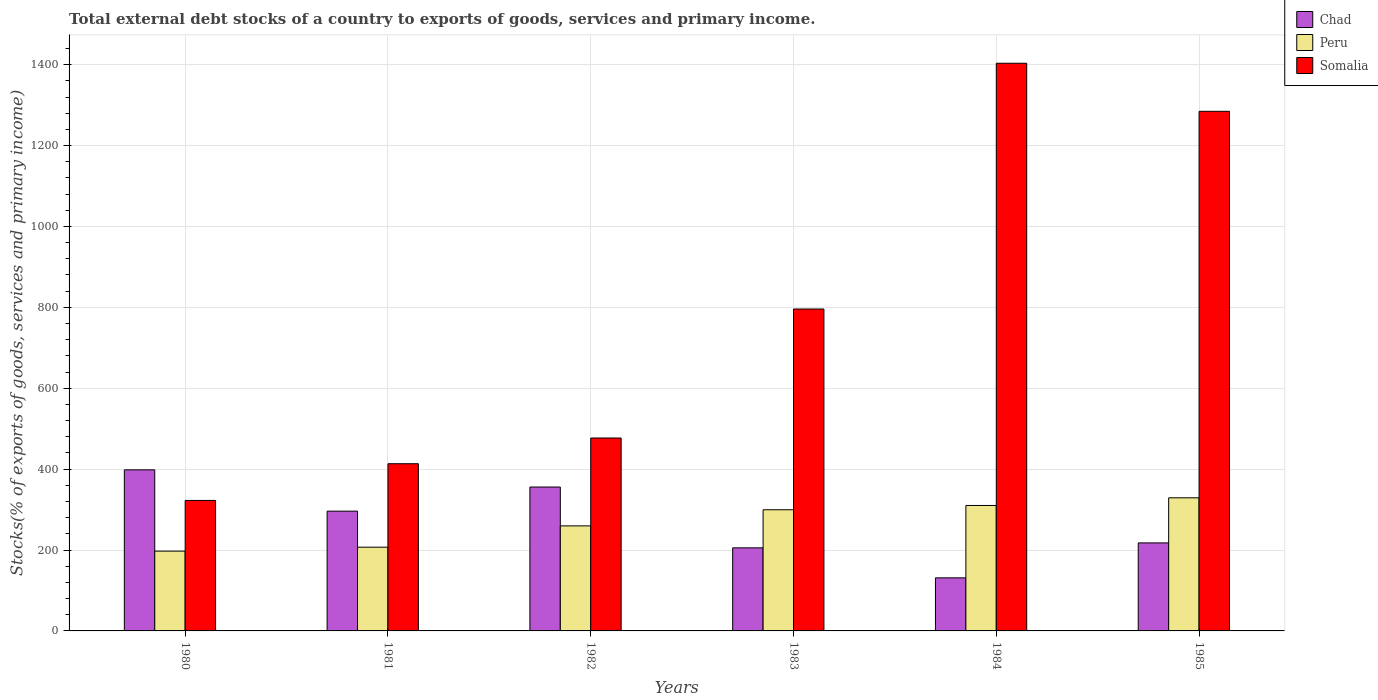How many groups of bars are there?
Give a very brief answer. 6. Are the number of bars per tick equal to the number of legend labels?
Offer a very short reply. Yes. Are the number of bars on each tick of the X-axis equal?
Offer a very short reply. Yes. What is the label of the 1st group of bars from the left?
Offer a terse response. 1980. In how many cases, is the number of bars for a given year not equal to the number of legend labels?
Provide a succinct answer. 0. What is the total debt stocks in Chad in 1981?
Offer a very short reply. 296.1. Across all years, what is the maximum total debt stocks in Peru?
Make the answer very short. 329.13. Across all years, what is the minimum total debt stocks in Chad?
Keep it short and to the point. 131.2. In which year was the total debt stocks in Peru minimum?
Your answer should be compact. 1980. What is the total total debt stocks in Peru in the graph?
Your answer should be compact. 1602.91. What is the difference between the total debt stocks in Somalia in 1982 and that in 1985?
Provide a short and direct response. -807.72. What is the difference between the total debt stocks in Peru in 1982 and the total debt stocks in Chad in 1983?
Offer a terse response. 54.3. What is the average total debt stocks in Chad per year?
Keep it short and to the point. 267.39. In the year 1980, what is the difference between the total debt stocks in Chad and total debt stocks in Somalia?
Provide a succinct answer. 75.62. What is the ratio of the total debt stocks in Chad in 1980 to that in 1983?
Provide a succinct answer. 1.94. Is the total debt stocks in Somalia in 1984 less than that in 1985?
Your answer should be very brief. No. Is the difference between the total debt stocks in Chad in 1980 and 1983 greater than the difference between the total debt stocks in Somalia in 1980 and 1983?
Your answer should be very brief. Yes. What is the difference between the highest and the second highest total debt stocks in Chad?
Provide a short and direct response. 42.5. What is the difference between the highest and the lowest total debt stocks in Somalia?
Offer a very short reply. 1080.82. In how many years, is the total debt stocks in Somalia greater than the average total debt stocks in Somalia taken over all years?
Ensure brevity in your answer.  3. What does the 1st bar from the left in 1983 represents?
Keep it short and to the point. Chad. What does the 3rd bar from the right in 1983 represents?
Give a very brief answer. Chad. How many bars are there?
Offer a very short reply. 18. Are all the bars in the graph horizontal?
Keep it short and to the point. No. How many years are there in the graph?
Your response must be concise. 6. How many legend labels are there?
Keep it short and to the point. 3. How are the legend labels stacked?
Offer a terse response. Vertical. What is the title of the graph?
Your answer should be very brief. Total external debt stocks of a country to exports of goods, services and primary income. What is the label or title of the X-axis?
Keep it short and to the point. Years. What is the label or title of the Y-axis?
Give a very brief answer. Stocks(% of exports of goods, services and primary income). What is the Stocks(% of exports of goods, services and primary income) of Chad in 1980?
Your answer should be very brief. 398.26. What is the Stocks(% of exports of goods, services and primary income) of Peru in 1980?
Provide a succinct answer. 197.3. What is the Stocks(% of exports of goods, services and primary income) in Somalia in 1980?
Your response must be concise. 322.64. What is the Stocks(% of exports of goods, services and primary income) in Chad in 1981?
Offer a very short reply. 296.1. What is the Stocks(% of exports of goods, services and primary income) of Peru in 1981?
Your response must be concise. 207.03. What is the Stocks(% of exports of goods, services and primary income) in Somalia in 1981?
Provide a succinct answer. 413.36. What is the Stocks(% of exports of goods, services and primary income) in Chad in 1982?
Your response must be concise. 355.75. What is the Stocks(% of exports of goods, services and primary income) in Peru in 1982?
Ensure brevity in your answer.  259.7. What is the Stocks(% of exports of goods, services and primary income) in Somalia in 1982?
Provide a succinct answer. 476.97. What is the Stocks(% of exports of goods, services and primary income) in Chad in 1983?
Offer a terse response. 205.4. What is the Stocks(% of exports of goods, services and primary income) of Peru in 1983?
Give a very brief answer. 299.59. What is the Stocks(% of exports of goods, services and primary income) in Somalia in 1983?
Your answer should be very brief. 795.87. What is the Stocks(% of exports of goods, services and primary income) in Chad in 1984?
Your answer should be very brief. 131.2. What is the Stocks(% of exports of goods, services and primary income) of Peru in 1984?
Your response must be concise. 310.16. What is the Stocks(% of exports of goods, services and primary income) of Somalia in 1984?
Your response must be concise. 1403.46. What is the Stocks(% of exports of goods, services and primary income) in Chad in 1985?
Your response must be concise. 217.61. What is the Stocks(% of exports of goods, services and primary income) of Peru in 1985?
Your answer should be compact. 329.13. What is the Stocks(% of exports of goods, services and primary income) in Somalia in 1985?
Offer a very short reply. 1284.68. Across all years, what is the maximum Stocks(% of exports of goods, services and primary income) in Chad?
Ensure brevity in your answer.  398.26. Across all years, what is the maximum Stocks(% of exports of goods, services and primary income) of Peru?
Provide a short and direct response. 329.13. Across all years, what is the maximum Stocks(% of exports of goods, services and primary income) of Somalia?
Give a very brief answer. 1403.46. Across all years, what is the minimum Stocks(% of exports of goods, services and primary income) in Chad?
Your answer should be compact. 131.2. Across all years, what is the minimum Stocks(% of exports of goods, services and primary income) of Peru?
Offer a very short reply. 197.3. Across all years, what is the minimum Stocks(% of exports of goods, services and primary income) of Somalia?
Give a very brief answer. 322.64. What is the total Stocks(% of exports of goods, services and primary income) of Chad in the graph?
Provide a short and direct response. 1604.32. What is the total Stocks(% of exports of goods, services and primary income) of Peru in the graph?
Provide a succinct answer. 1602.91. What is the total Stocks(% of exports of goods, services and primary income) of Somalia in the graph?
Ensure brevity in your answer.  4696.98. What is the difference between the Stocks(% of exports of goods, services and primary income) in Chad in 1980 and that in 1981?
Provide a succinct answer. 102.15. What is the difference between the Stocks(% of exports of goods, services and primary income) of Peru in 1980 and that in 1981?
Your response must be concise. -9.73. What is the difference between the Stocks(% of exports of goods, services and primary income) in Somalia in 1980 and that in 1981?
Provide a short and direct response. -90.72. What is the difference between the Stocks(% of exports of goods, services and primary income) in Chad in 1980 and that in 1982?
Your answer should be compact. 42.5. What is the difference between the Stocks(% of exports of goods, services and primary income) of Peru in 1980 and that in 1982?
Your response must be concise. -62.4. What is the difference between the Stocks(% of exports of goods, services and primary income) in Somalia in 1980 and that in 1982?
Offer a terse response. -154.33. What is the difference between the Stocks(% of exports of goods, services and primary income) of Chad in 1980 and that in 1983?
Offer a terse response. 192.85. What is the difference between the Stocks(% of exports of goods, services and primary income) of Peru in 1980 and that in 1983?
Ensure brevity in your answer.  -102.29. What is the difference between the Stocks(% of exports of goods, services and primary income) of Somalia in 1980 and that in 1983?
Your answer should be very brief. -473.23. What is the difference between the Stocks(% of exports of goods, services and primary income) in Chad in 1980 and that in 1984?
Your response must be concise. 267.06. What is the difference between the Stocks(% of exports of goods, services and primary income) of Peru in 1980 and that in 1984?
Your response must be concise. -112.86. What is the difference between the Stocks(% of exports of goods, services and primary income) in Somalia in 1980 and that in 1984?
Your answer should be compact. -1080.82. What is the difference between the Stocks(% of exports of goods, services and primary income) in Chad in 1980 and that in 1985?
Your answer should be very brief. 180.65. What is the difference between the Stocks(% of exports of goods, services and primary income) of Peru in 1980 and that in 1985?
Give a very brief answer. -131.83. What is the difference between the Stocks(% of exports of goods, services and primary income) of Somalia in 1980 and that in 1985?
Ensure brevity in your answer.  -962.05. What is the difference between the Stocks(% of exports of goods, services and primary income) of Chad in 1981 and that in 1982?
Give a very brief answer. -59.65. What is the difference between the Stocks(% of exports of goods, services and primary income) of Peru in 1981 and that in 1982?
Provide a succinct answer. -52.67. What is the difference between the Stocks(% of exports of goods, services and primary income) of Somalia in 1981 and that in 1982?
Ensure brevity in your answer.  -63.61. What is the difference between the Stocks(% of exports of goods, services and primary income) in Chad in 1981 and that in 1983?
Keep it short and to the point. 90.7. What is the difference between the Stocks(% of exports of goods, services and primary income) in Peru in 1981 and that in 1983?
Your answer should be very brief. -92.56. What is the difference between the Stocks(% of exports of goods, services and primary income) of Somalia in 1981 and that in 1983?
Make the answer very short. -382.51. What is the difference between the Stocks(% of exports of goods, services and primary income) of Chad in 1981 and that in 1984?
Offer a very short reply. 164.91. What is the difference between the Stocks(% of exports of goods, services and primary income) in Peru in 1981 and that in 1984?
Provide a short and direct response. -103.13. What is the difference between the Stocks(% of exports of goods, services and primary income) of Somalia in 1981 and that in 1984?
Your answer should be compact. -990.1. What is the difference between the Stocks(% of exports of goods, services and primary income) in Chad in 1981 and that in 1985?
Offer a terse response. 78.49. What is the difference between the Stocks(% of exports of goods, services and primary income) in Peru in 1981 and that in 1985?
Provide a succinct answer. -122.1. What is the difference between the Stocks(% of exports of goods, services and primary income) in Somalia in 1981 and that in 1985?
Your answer should be compact. -871.33. What is the difference between the Stocks(% of exports of goods, services and primary income) of Chad in 1982 and that in 1983?
Your answer should be compact. 150.35. What is the difference between the Stocks(% of exports of goods, services and primary income) in Peru in 1982 and that in 1983?
Give a very brief answer. -39.89. What is the difference between the Stocks(% of exports of goods, services and primary income) in Somalia in 1982 and that in 1983?
Keep it short and to the point. -318.9. What is the difference between the Stocks(% of exports of goods, services and primary income) of Chad in 1982 and that in 1984?
Make the answer very short. 224.56. What is the difference between the Stocks(% of exports of goods, services and primary income) in Peru in 1982 and that in 1984?
Keep it short and to the point. -50.45. What is the difference between the Stocks(% of exports of goods, services and primary income) in Somalia in 1982 and that in 1984?
Your answer should be compact. -926.49. What is the difference between the Stocks(% of exports of goods, services and primary income) in Chad in 1982 and that in 1985?
Offer a very short reply. 138.14. What is the difference between the Stocks(% of exports of goods, services and primary income) of Peru in 1982 and that in 1985?
Your response must be concise. -69.43. What is the difference between the Stocks(% of exports of goods, services and primary income) of Somalia in 1982 and that in 1985?
Make the answer very short. -807.72. What is the difference between the Stocks(% of exports of goods, services and primary income) of Chad in 1983 and that in 1984?
Give a very brief answer. 74.21. What is the difference between the Stocks(% of exports of goods, services and primary income) in Peru in 1983 and that in 1984?
Offer a very short reply. -10.57. What is the difference between the Stocks(% of exports of goods, services and primary income) of Somalia in 1983 and that in 1984?
Give a very brief answer. -607.59. What is the difference between the Stocks(% of exports of goods, services and primary income) of Chad in 1983 and that in 1985?
Give a very brief answer. -12.2. What is the difference between the Stocks(% of exports of goods, services and primary income) in Peru in 1983 and that in 1985?
Your response must be concise. -29.54. What is the difference between the Stocks(% of exports of goods, services and primary income) of Somalia in 1983 and that in 1985?
Keep it short and to the point. -488.81. What is the difference between the Stocks(% of exports of goods, services and primary income) in Chad in 1984 and that in 1985?
Your answer should be compact. -86.41. What is the difference between the Stocks(% of exports of goods, services and primary income) of Peru in 1984 and that in 1985?
Offer a terse response. -18.97. What is the difference between the Stocks(% of exports of goods, services and primary income) of Somalia in 1984 and that in 1985?
Your answer should be very brief. 118.78. What is the difference between the Stocks(% of exports of goods, services and primary income) of Chad in 1980 and the Stocks(% of exports of goods, services and primary income) of Peru in 1981?
Keep it short and to the point. 191.23. What is the difference between the Stocks(% of exports of goods, services and primary income) of Chad in 1980 and the Stocks(% of exports of goods, services and primary income) of Somalia in 1981?
Offer a very short reply. -15.1. What is the difference between the Stocks(% of exports of goods, services and primary income) in Peru in 1980 and the Stocks(% of exports of goods, services and primary income) in Somalia in 1981?
Give a very brief answer. -216.06. What is the difference between the Stocks(% of exports of goods, services and primary income) of Chad in 1980 and the Stocks(% of exports of goods, services and primary income) of Peru in 1982?
Offer a terse response. 138.55. What is the difference between the Stocks(% of exports of goods, services and primary income) in Chad in 1980 and the Stocks(% of exports of goods, services and primary income) in Somalia in 1982?
Your answer should be very brief. -78.71. What is the difference between the Stocks(% of exports of goods, services and primary income) of Peru in 1980 and the Stocks(% of exports of goods, services and primary income) of Somalia in 1982?
Your answer should be very brief. -279.67. What is the difference between the Stocks(% of exports of goods, services and primary income) in Chad in 1980 and the Stocks(% of exports of goods, services and primary income) in Peru in 1983?
Offer a very short reply. 98.67. What is the difference between the Stocks(% of exports of goods, services and primary income) of Chad in 1980 and the Stocks(% of exports of goods, services and primary income) of Somalia in 1983?
Provide a short and direct response. -397.61. What is the difference between the Stocks(% of exports of goods, services and primary income) of Peru in 1980 and the Stocks(% of exports of goods, services and primary income) of Somalia in 1983?
Offer a terse response. -598.57. What is the difference between the Stocks(% of exports of goods, services and primary income) in Chad in 1980 and the Stocks(% of exports of goods, services and primary income) in Peru in 1984?
Provide a short and direct response. 88.1. What is the difference between the Stocks(% of exports of goods, services and primary income) of Chad in 1980 and the Stocks(% of exports of goods, services and primary income) of Somalia in 1984?
Your answer should be very brief. -1005.2. What is the difference between the Stocks(% of exports of goods, services and primary income) of Peru in 1980 and the Stocks(% of exports of goods, services and primary income) of Somalia in 1984?
Your answer should be compact. -1206.16. What is the difference between the Stocks(% of exports of goods, services and primary income) in Chad in 1980 and the Stocks(% of exports of goods, services and primary income) in Peru in 1985?
Your answer should be very brief. 69.13. What is the difference between the Stocks(% of exports of goods, services and primary income) in Chad in 1980 and the Stocks(% of exports of goods, services and primary income) in Somalia in 1985?
Offer a terse response. -886.43. What is the difference between the Stocks(% of exports of goods, services and primary income) in Peru in 1980 and the Stocks(% of exports of goods, services and primary income) in Somalia in 1985?
Offer a terse response. -1087.38. What is the difference between the Stocks(% of exports of goods, services and primary income) of Chad in 1981 and the Stocks(% of exports of goods, services and primary income) of Peru in 1982?
Provide a succinct answer. 36.4. What is the difference between the Stocks(% of exports of goods, services and primary income) of Chad in 1981 and the Stocks(% of exports of goods, services and primary income) of Somalia in 1982?
Your response must be concise. -180.86. What is the difference between the Stocks(% of exports of goods, services and primary income) of Peru in 1981 and the Stocks(% of exports of goods, services and primary income) of Somalia in 1982?
Your answer should be very brief. -269.94. What is the difference between the Stocks(% of exports of goods, services and primary income) in Chad in 1981 and the Stocks(% of exports of goods, services and primary income) in Peru in 1983?
Keep it short and to the point. -3.49. What is the difference between the Stocks(% of exports of goods, services and primary income) of Chad in 1981 and the Stocks(% of exports of goods, services and primary income) of Somalia in 1983?
Your answer should be very brief. -499.77. What is the difference between the Stocks(% of exports of goods, services and primary income) of Peru in 1981 and the Stocks(% of exports of goods, services and primary income) of Somalia in 1983?
Keep it short and to the point. -588.84. What is the difference between the Stocks(% of exports of goods, services and primary income) in Chad in 1981 and the Stocks(% of exports of goods, services and primary income) in Peru in 1984?
Keep it short and to the point. -14.06. What is the difference between the Stocks(% of exports of goods, services and primary income) of Chad in 1981 and the Stocks(% of exports of goods, services and primary income) of Somalia in 1984?
Your answer should be very brief. -1107.36. What is the difference between the Stocks(% of exports of goods, services and primary income) of Peru in 1981 and the Stocks(% of exports of goods, services and primary income) of Somalia in 1984?
Ensure brevity in your answer.  -1196.43. What is the difference between the Stocks(% of exports of goods, services and primary income) of Chad in 1981 and the Stocks(% of exports of goods, services and primary income) of Peru in 1985?
Give a very brief answer. -33.03. What is the difference between the Stocks(% of exports of goods, services and primary income) in Chad in 1981 and the Stocks(% of exports of goods, services and primary income) in Somalia in 1985?
Provide a succinct answer. -988.58. What is the difference between the Stocks(% of exports of goods, services and primary income) in Peru in 1981 and the Stocks(% of exports of goods, services and primary income) in Somalia in 1985?
Provide a succinct answer. -1077.66. What is the difference between the Stocks(% of exports of goods, services and primary income) in Chad in 1982 and the Stocks(% of exports of goods, services and primary income) in Peru in 1983?
Keep it short and to the point. 56.16. What is the difference between the Stocks(% of exports of goods, services and primary income) in Chad in 1982 and the Stocks(% of exports of goods, services and primary income) in Somalia in 1983?
Your answer should be compact. -440.12. What is the difference between the Stocks(% of exports of goods, services and primary income) in Peru in 1982 and the Stocks(% of exports of goods, services and primary income) in Somalia in 1983?
Your response must be concise. -536.17. What is the difference between the Stocks(% of exports of goods, services and primary income) in Chad in 1982 and the Stocks(% of exports of goods, services and primary income) in Peru in 1984?
Ensure brevity in your answer.  45.59. What is the difference between the Stocks(% of exports of goods, services and primary income) in Chad in 1982 and the Stocks(% of exports of goods, services and primary income) in Somalia in 1984?
Provide a succinct answer. -1047.71. What is the difference between the Stocks(% of exports of goods, services and primary income) in Peru in 1982 and the Stocks(% of exports of goods, services and primary income) in Somalia in 1984?
Provide a succinct answer. -1143.76. What is the difference between the Stocks(% of exports of goods, services and primary income) of Chad in 1982 and the Stocks(% of exports of goods, services and primary income) of Peru in 1985?
Your answer should be very brief. 26.62. What is the difference between the Stocks(% of exports of goods, services and primary income) of Chad in 1982 and the Stocks(% of exports of goods, services and primary income) of Somalia in 1985?
Your response must be concise. -928.93. What is the difference between the Stocks(% of exports of goods, services and primary income) of Peru in 1982 and the Stocks(% of exports of goods, services and primary income) of Somalia in 1985?
Your answer should be compact. -1024.98. What is the difference between the Stocks(% of exports of goods, services and primary income) in Chad in 1983 and the Stocks(% of exports of goods, services and primary income) in Peru in 1984?
Ensure brevity in your answer.  -104.75. What is the difference between the Stocks(% of exports of goods, services and primary income) of Chad in 1983 and the Stocks(% of exports of goods, services and primary income) of Somalia in 1984?
Give a very brief answer. -1198.06. What is the difference between the Stocks(% of exports of goods, services and primary income) of Peru in 1983 and the Stocks(% of exports of goods, services and primary income) of Somalia in 1984?
Make the answer very short. -1103.87. What is the difference between the Stocks(% of exports of goods, services and primary income) in Chad in 1983 and the Stocks(% of exports of goods, services and primary income) in Peru in 1985?
Your answer should be compact. -123.73. What is the difference between the Stocks(% of exports of goods, services and primary income) in Chad in 1983 and the Stocks(% of exports of goods, services and primary income) in Somalia in 1985?
Offer a terse response. -1079.28. What is the difference between the Stocks(% of exports of goods, services and primary income) in Peru in 1983 and the Stocks(% of exports of goods, services and primary income) in Somalia in 1985?
Your answer should be compact. -985.09. What is the difference between the Stocks(% of exports of goods, services and primary income) of Chad in 1984 and the Stocks(% of exports of goods, services and primary income) of Peru in 1985?
Ensure brevity in your answer.  -197.93. What is the difference between the Stocks(% of exports of goods, services and primary income) in Chad in 1984 and the Stocks(% of exports of goods, services and primary income) in Somalia in 1985?
Your response must be concise. -1153.49. What is the difference between the Stocks(% of exports of goods, services and primary income) in Peru in 1984 and the Stocks(% of exports of goods, services and primary income) in Somalia in 1985?
Offer a terse response. -974.53. What is the average Stocks(% of exports of goods, services and primary income) of Chad per year?
Your answer should be very brief. 267.39. What is the average Stocks(% of exports of goods, services and primary income) in Peru per year?
Ensure brevity in your answer.  267.15. What is the average Stocks(% of exports of goods, services and primary income) in Somalia per year?
Offer a terse response. 782.83. In the year 1980, what is the difference between the Stocks(% of exports of goods, services and primary income) of Chad and Stocks(% of exports of goods, services and primary income) of Peru?
Make the answer very short. 200.96. In the year 1980, what is the difference between the Stocks(% of exports of goods, services and primary income) of Chad and Stocks(% of exports of goods, services and primary income) of Somalia?
Make the answer very short. 75.62. In the year 1980, what is the difference between the Stocks(% of exports of goods, services and primary income) in Peru and Stocks(% of exports of goods, services and primary income) in Somalia?
Offer a terse response. -125.34. In the year 1981, what is the difference between the Stocks(% of exports of goods, services and primary income) of Chad and Stocks(% of exports of goods, services and primary income) of Peru?
Keep it short and to the point. 89.07. In the year 1981, what is the difference between the Stocks(% of exports of goods, services and primary income) in Chad and Stocks(% of exports of goods, services and primary income) in Somalia?
Your response must be concise. -117.26. In the year 1981, what is the difference between the Stocks(% of exports of goods, services and primary income) of Peru and Stocks(% of exports of goods, services and primary income) of Somalia?
Ensure brevity in your answer.  -206.33. In the year 1982, what is the difference between the Stocks(% of exports of goods, services and primary income) of Chad and Stocks(% of exports of goods, services and primary income) of Peru?
Keep it short and to the point. 96.05. In the year 1982, what is the difference between the Stocks(% of exports of goods, services and primary income) of Chad and Stocks(% of exports of goods, services and primary income) of Somalia?
Offer a very short reply. -121.22. In the year 1982, what is the difference between the Stocks(% of exports of goods, services and primary income) in Peru and Stocks(% of exports of goods, services and primary income) in Somalia?
Offer a terse response. -217.26. In the year 1983, what is the difference between the Stocks(% of exports of goods, services and primary income) of Chad and Stocks(% of exports of goods, services and primary income) of Peru?
Your answer should be compact. -94.18. In the year 1983, what is the difference between the Stocks(% of exports of goods, services and primary income) in Chad and Stocks(% of exports of goods, services and primary income) in Somalia?
Keep it short and to the point. -590.46. In the year 1983, what is the difference between the Stocks(% of exports of goods, services and primary income) in Peru and Stocks(% of exports of goods, services and primary income) in Somalia?
Offer a terse response. -496.28. In the year 1984, what is the difference between the Stocks(% of exports of goods, services and primary income) of Chad and Stocks(% of exports of goods, services and primary income) of Peru?
Provide a succinct answer. -178.96. In the year 1984, what is the difference between the Stocks(% of exports of goods, services and primary income) of Chad and Stocks(% of exports of goods, services and primary income) of Somalia?
Provide a short and direct response. -1272.27. In the year 1984, what is the difference between the Stocks(% of exports of goods, services and primary income) of Peru and Stocks(% of exports of goods, services and primary income) of Somalia?
Keep it short and to the point. -1093.3. In the year 1985, what is the difference between the Stocks(% of exports of goods, services and primary income) of Chad and Stocks(% of exports of goods, services and primary income) of Peru?
Provide a short and direct response. -111.52. In the year 1985, what is the difference between the Stocks(% of exports of goods, services and primary income) in Chad and Stocks(% of exports of goods, services and primary income) in Somalia?
Offer a very short reply. -1067.08. In the year 1985, what is the difference between the Stocks(% of exports of goods, services and primary income) of Peru and Stocks(% of exports of goods, services and primary income) of Somalia?
Give a very brief answer. -955.55. What is the ratio of the Stocks(% of exports of goods, services and primary income) in Chad in 1980 to that in 1981?
Ensure brevity in your answer.  1.34. What is the ratio of the Stocks(% of exports of goods, services and primary income) of Peru in 1980 to that in 1981?
Give a very brief answer. 0.95. What is the ratio of the Stocks(% of exports of goods, services and primary income) in Somalia in 1980 to that in 1981?
Provide a succinct answer. 0.78. What is the ratio of the Stocks(% of exports of goods, services and primary income) in Chad in 1980 to that in 1982?
Keep it short and to the point. 1.12. What is the ratio of the Stocks(% of exports of goods, services and primary income) in Peru in 1980 to that in 1982?
Give a very brief answer. 0.76. What is the ratio of the Stocks(% of exports of goods, services and primary income) in Somalia in 1980 to that in 1982?
Your answer should be very brief. 0.68. What is the ratio of the Stocks(% of exports of goods, services and primary income) in Chad in 1980 to that in 1983?
Keep it short and to the point. 1.94. What is the ratio of the Stocks(% of exports of goods, services and primary income) in Peru in 1980 to that in 1983?
Give a very brief answer. 0.66. What is the ratio of the Stocks(% of exports of goods, services and primary income) in Somalia in 1980 to that in 1983?
Ensure brevity in your answer.  0.41. What is the ratio of the Stocks(% of exports of goods, services and primary income) of Chad in 1980 to that in 1984?
Offer a very short reply. 3.04. What is the ratio of the Stocks(% of exports of goods, services and primary income) of Peru in 1980 to that in 1984?
Keep it short and to the point. 0.64. What is the ratio of the Stocks(% of exports of goods, services and primary income) in Somalia in 1980 to that in 1984?
Offer a very short reply. 0.23. What is the ratio of the Stocks(% of exports of goods, services and primary income) of Chad in 1980 to that in 1985?
Ensure brevity in your answer.  1.83. What is the ratio of the Stocks(% of exports of goods, services and primary income) in Peru in 1980 to that in 1985?
Your answer should be compact. 0.6. What is the ratio of the Stocks(% of exports of goods, services and primary income) of Somalia in 1980 to that in 1985?
Keep it short and to the point. 0.25. What is the ratio of the Stocks(% of exports of goods, services and primary income) in Chad in 1981 to that in 1982?
Ensure brevity in your answer.  0.83. What is the ratio of the Stocks(% of exports of goods, services and primary income) of Peru in 1981 to that in 1982?
Make the answer very short. 0.8. What is the ratio of the Stocks(% of exports of goods, services and primary income) of Somalia in 1981 to that in 1982?
Provide a succinct answer. 0.87. What is the ratio of the Stocks(% of exports of goods, services and primary income) in Chad in 1981 to that in 1983?
Give a very brief answer. 1.44. What is the ratio of the Stocks(% of exports of goods, services and primary income) in Peru in 1981 to that in 1983?
Your answer should be compact. 0.69. What is the ratio of the Stocks(% of exports of goods, services and primary income) of Somalia in 1981 to that in 1983?
Your answer should be compact. 0.52. What is the ratio of the Stocks(% of exports of goods, services and primary income) in Chad in 1981 to that in 1984?
Provide a succinct answer. 2.26. What is the ratio of the Stocks(% of exports of goods, services and primary income) of Peru in 1981 to that in 1984?
Provide a short and direct response. 0.67. What is the ratio of the Stocks(% of exports of goods, services and primary income) in Somalia in 1981 to that in 1984?
Your response must be concise. 0.29. What is the ratio of the Stocks(% of exports of goods, services and primary income) of Chad in 1981 to that in 1985?
Your answer should be very brief. 1.36. What is the ratio of the Stocks(% of exports of goods, services and primary income) of Peru in 1981 to that in 1985?
Your answer should be compact. 0.63. What is the ratio of the Stocks(% of exports of goods, services and primary income) in Somalia in 1981 to that in 1985?
Ensure brevity in your answer.  0.32. What is the ratio of the Stocks(% of exports of goods, services and primary income) in Chad in 1982 to that in 1983?
Your response must be concise. 1.73. What is the ratio of the Stocks(% of exports of goods, services and primary income) of Peru in 1982 to that in 1983?
Offer a terse response. 0.87. What is the ratio of the Stocks(% of exports of goods, services and primary income) of Somalia in 1982 to that in 1983?
Keep it short and to the point. 0.6. What is the ratio of the Stocks(% of exports of goods, services and primary income) in Chad in 1982 to that in 1984?
Offer a terse response. 2.71. What is the ratio of the Stocks(% of exports of goods, services and primary income) in Peru in 1982 to that in 1984?
Ensure brevity in your answer.  0.84. What is the ratio of the Stocks(% of exports of goods, services and primary income) of Somalia in 1982 to that in 1984?
Your answer should be very brief. 0.34. What is the ratio of the Stocks(% of exports of goods, services and primary income) of Chad in 1982 to that in 1985?
Offer a very short reply. 1.63. What is the ratio of the Stocks(% of exports of goods, services and primary income) of Peru in 1982 to that in 1985?
Make the answer very short. 0.79. What is the ratio of the Stocks(% of exports of goods, services and primary income) in Somalia in 1982 to that in 1985?
Your response must be concise. 0.37. What is the ratio of the Stocks(% of exports of goods, services and primary income) in Chad in 1983 to that in 1984?
Make the answer very short. 1.57. What is the ratio of the Stocks(% of exports of goods, services and primary income) in Peru in 1983 to that in 1984?
Your answer should be compact. 0.97. What is the ratio of the Stocks(% of exports of goods, services and primary income) in Somalia in 1983 to that in 1984?
Your answer should be very brief. 0.57. What is the ratio of the Stocks(% of exports of goods, services and primary income) of Chad in 1983 to that in 1985?
Make the answer very short. 0.94. What is the ratio of the Stocks(% of exports of goods, services and primary income) in Peru in 1983 to that in 1985?
Give a very brief answer. 0.91. What is the ratio of the Stocks(% of exports of goods, services and primary income) in Somalia in 1983 to that in 1985?
Your answer should be very brief. 0.62. What is the ratio of the Stocks(% of exports of goods, services and primary income) of Chad in 1984 to that in 1985?
Offer a very short reply. 0.6. What is the ratio of the Stocks(% of exports of goods, services and primary income) of Peru in 1984 to that in 1985?
Your answer should be compact. 0.94. What is the ratio of the Stocks(% of exports of goods, services and primary income) in Somalia in 1984 to that in 1985?
Provide a short and direct response. 1.09. What is the difference between the highest and the second highest Stocks(% of exports of goods, services and primary income) in Chad?
Give a very brief answer. 42.5. What is the difference between the highest and the second highest Stocks(% of exports of goods, services and primary income) in Peru?
Your answer should be compact. 18.97. What is the difference between the highest and the second highest Stocks(% of exports of goods, services and primary income) of Somalia?
Your answer should be very brief. 118.78. What is the difference between the highest and the lowest Stocks(% of exports of goods, services and primary income) of Chad?
Provide a short and direct response. 267.06. What is the difference between the highest and the lowest Stocks(% of exports of goods, services and primary income) in Peru?
Give a very brief answer. 131.83. What is the difference between the highest and the lowest Stocks(% of exports of goods, services and primary income) of Somalia?
Provide a succinct answer. 1080.82. 